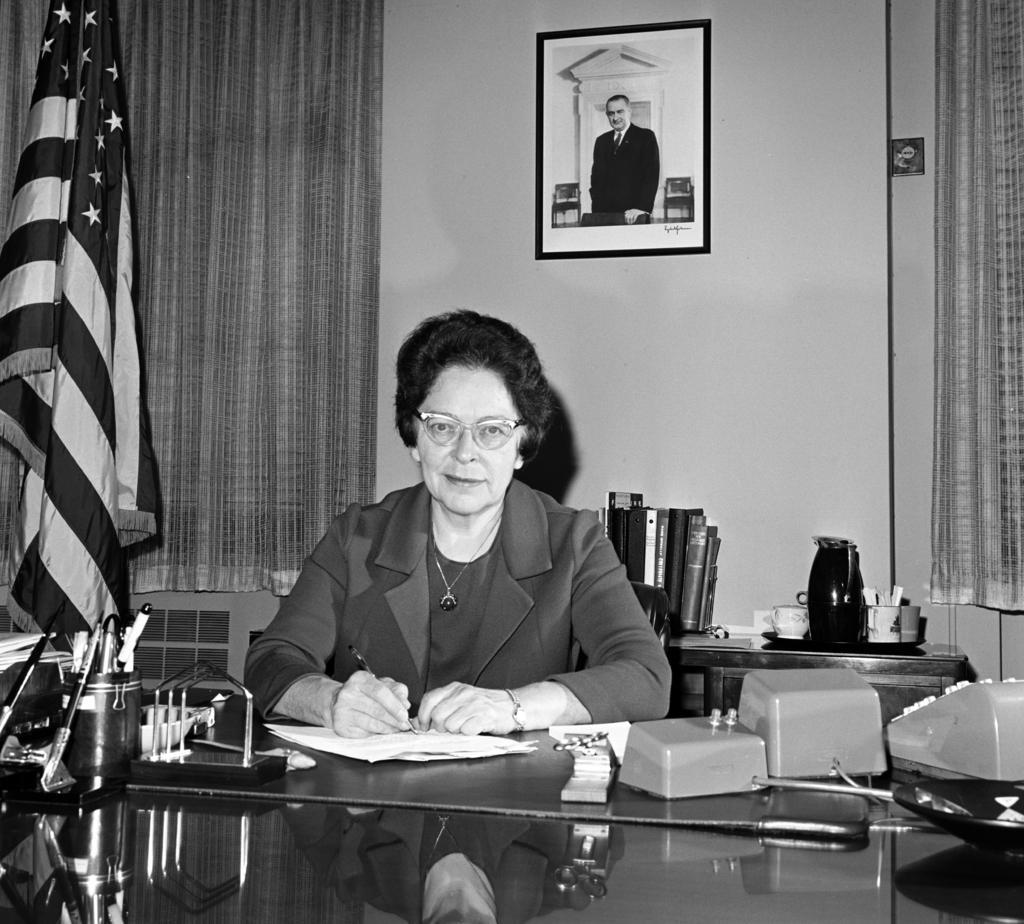Could you give a brief overview of what you see in this image? In this picture there is a woman sitting on the chair. She is wearing spectacle on her eyes and is holding a pen in her hand. She is writing with a pen on the paper. On to the left, there is a flag and a curtain. There is a frame in which a man is there in the frame. The frame is hung on the wall. At the back there are some files. There is a cup and a jug placed on a table. 